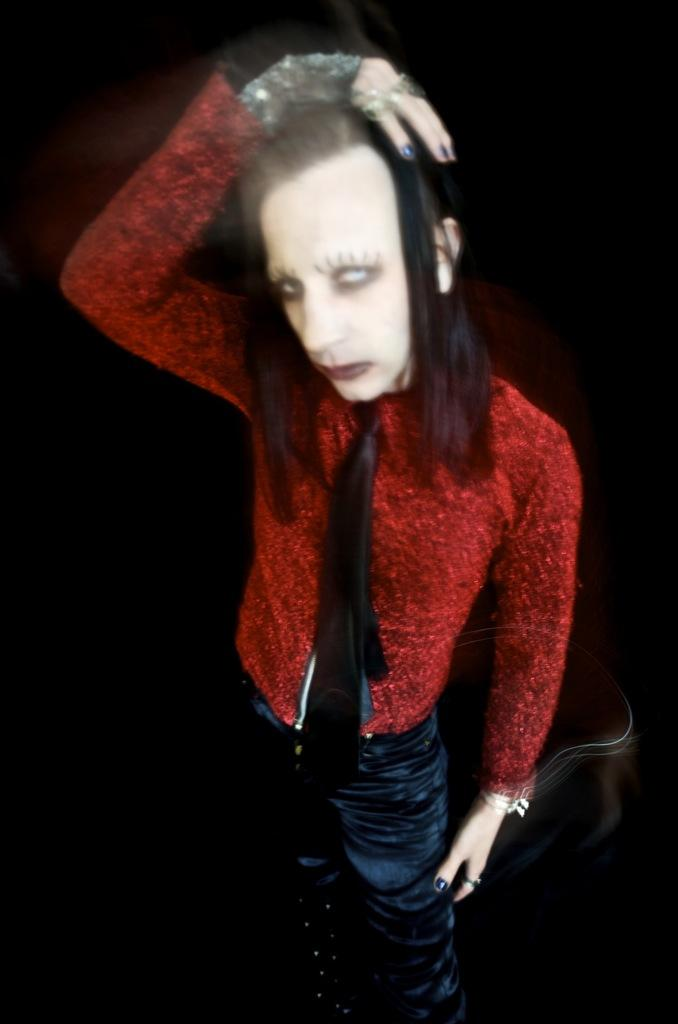What is the main subject of the image? There is a person standing in the image. What is the person wearing? The person is wearing a red and black color dress. Can you describe the background of the image? The background of the image is dark. How many tomatoes can be seen on the person's head in the image? There are no tomatoes present in the image, so it is not possible to determine how many there might be on the person's head. 